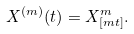<formula> <loc_0><loc_0><loc_500><loc_500>X ^ { ( m ) } ( t ) = X ^ { m } _ { [ m t ] } .</formula> 